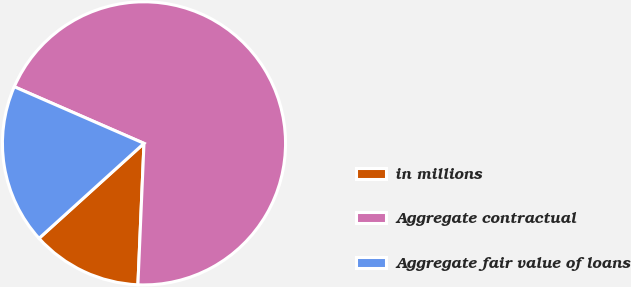Convert chart to OTSL. <chart><loc_0><loc_0><loc_500><loc_500><pie_chart><fcel>in millions<fcel>Aggregate contractual<fcel>Aggregate fair value of loans<nl><fcel>12.61%<fcel>69.14%<fcel>18.26%<nl></chart> 